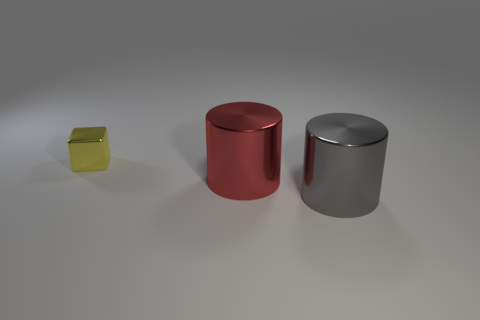Is there anything else that is the same shape as the tiny yellow object?
Keep it short and to the point. No. There is a metallic cylinder that is in front of the metallic cylinder behind the cylinder that is right of the red thing; what size is it?
Ensure brevity in your answer.  Large. There is another shiny thing that is the same size as the gray metal thing; what is its shape?
Offer a very short reply. Cylinder. How many small things are either cylinders or purple metal cylinders?
Make the answer very short. 0. Are there any large shiny cylinders in front of the cylinder behind the large metal object in front of the red cylinder?
Your answer should be very brief. Yes. Is there a red cylinder of the same size as the gray metallic object?
Your answer should be very brief. Yes. There is a red object that is the same size as the gray metal cylinder; what material is it?
Offer a very short reply. Metal. There is a gray thing; is its size the same as the metal cylinder behind the large gray thing?
Offer a very short reply. Yes. What number of rubber objects are large gray cylinders or small gray things?
Give a very brief answer. 0. How many other gray shiny objects have the same shape as the small metal object?
Your response must be concise. 0. 